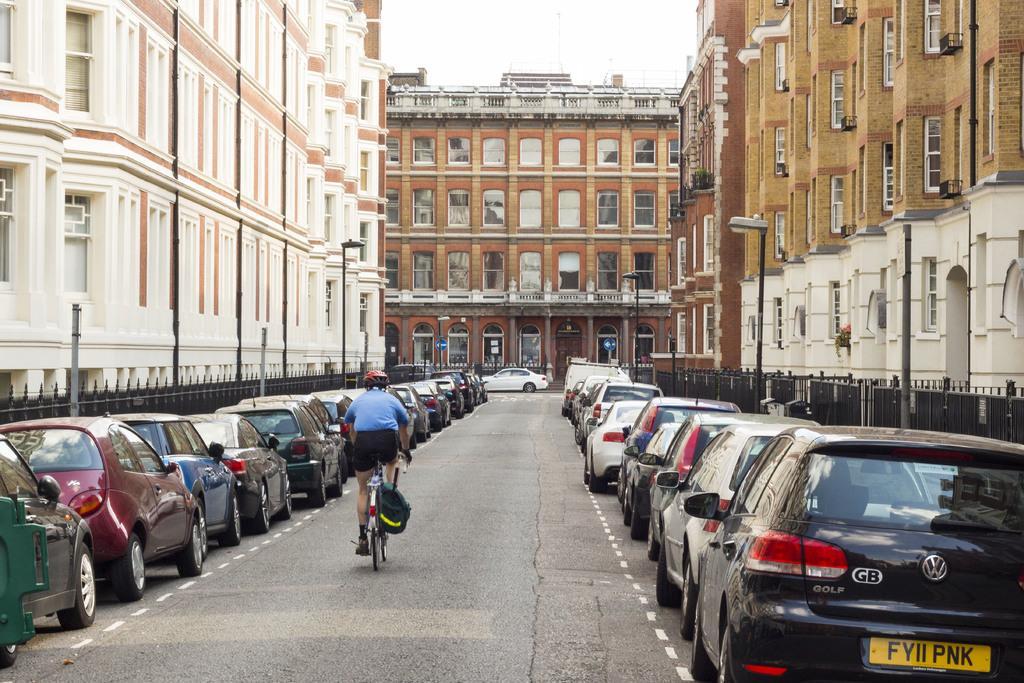Can you describe this image briefly? There is a person riding bicycle and wore helmet. We can see buildings,lights on poles and sky. 